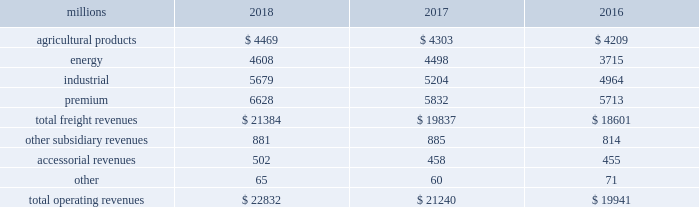Notes to the consolidated financial statements union pacific corporation and subsidiary companies for purposes of this report , unless the context otherwise requires , all references herein to the 201ccorporation 201d , 201ccompany 201d , 201cupc 201d , 201cwe 201d , 201cus 201d , and 201cour 201d mean union pacific corporation and its subsidiaries , including union pacific railroad company , which will be separately referred to herein as 201cuprr 201d or the 201crailroad 201d .
Nature of operations operations and segmentation 2013 we are a class i railroad operating in the u.s .
Our network includes 32236 route miles , linking pacific coast and gulf coast ports with the midwest and eastern u.s .
Gateways and providing several corridors to key mexican gateways .
We own 26039 miles and operate on the remainder pursuant to trackage rights or leases .
We serve the western two-thirds of the country and maintain coordinated schedules with other rail carriers for the handling of freight to and from the atlantic coast , the pacific coast , the southeast , the southwest , canada , and mexico .
Export and import traffic is moved through gulf coast and pacific coast ports and across the mexican and canadian borders .
The railroad , along with its subsidiaries and rail affiliates , is our one reportable operating segment .
Although we provide and analyze revenue by commodity group , we treat the financial results of the railroad as one segment due to the integrated nature of our rail network .
Our operating revenues are primarily derived from contracts with customers for the transportation of freight from origin to destination .
Effective january 1 , 2018 , the company reclassified its six commodity groups into four : agricultural products , energy , industrial , and premium .
The table represents a disaggregation of our freight and other revenues: .
Although our revenues are principally derived from customers domiciled in the u.s. , the ultimate points of origination or destination for some products we transport are outside the u.s .
Each of our commodity groups includes revenue from shipments to and from mexico .
Included in the above table are freight revenues from our mexico business which amounted to $ 2.5 billion in 2018 , $ 2.3 billion in 2017 , and $ 2.2 billion in 2016 .
Basis of presentation 2013 the consolidated financial statements are presented in accordance with accounting principles generally accepted in the u.s .
( gaap ) as codified in the financial accounting standards board ( fasb ) accounting standards codification ( asc ) .
Significant accounting policies principles of consolidation 2013 the consolidated financial statements include the accounts of union pacific corporation and all of its subsidiaries .
Investments in affiliated companies ( 20% ( 20 % ) to 50% ( 50 % ) owned ) are accounted for using the equity method of accounting .
All intercompany transactions are eliminated .
We currently have no less than majority-owned investments that require consolidation under variable interest entity requirements .
Cash , cash equivalents and restricted cash 2013 cash equivalents consist of investments with original maturities of three months or less .
Amounts included in restricted cash represent those required to be set aside by contractual agreement. .
Assuming the same rate of growth as in 2018 , what would industrial segment revenues grow to in 2019? 
Computations: ((5679 / 5204) * 5679)
Answer: 6197.35607. Notes to the consolidated financial statements union pacific corporation and subsidiary companies for purposes of this report , unless the context otherwise requires , all references herein to the 201ccorporation 201d , 201ccompany 201d , 201cupc 201d , 201cwe 201d , 201cus 201d , and 201cour 201d mean union pacific corporation and its subsidiaries , including union pacific railroad company , which will be separately referred to herein as 201cuprr 201d or the 201crailroad 201d .
Nature of operations operations and segmentation 2013 we are a class i railroad operating in the u.s .
Our network includes 32236 route miles , linking pacific coast and gulf coast ports with the midwest and eastern u.s .
Gateways and providing several corridors to key mexican gateways .
We own 26039 miles and operate on the remainder pursuant to trackage rights or leases .
We serve the western two-thirds of the country and maintain coordinated schedules with other rail carriers for the handling of freight to and from the atlantic coast , the pacific coast , the southeast , the southwest , canada , and mexico .
Export and import traffic is moved through gulf coast and pacific coast ports and across the mexican and canadian borders .
The railroad , along with its subsidiaries and rail affiliates , is our one reportable operating segment .
Although we provide and analyze revenue by commodity group , we treat the financial results of the railroad as one segment due to the integrated nature of our rail network .
Our operating revenues are primarily derived from contracts with customers for the transportation of freight from origin to destination .
Effective january 1 , 2018 , the company reclassified its six commodity groups into four : agricultural products , energy , industrial , and premium .
The table represents a disaggregation of our freight and other revenues: .
Although our revenues are principally derived from customers domiciled in the u.s. , the ultimate points of origination or destination for some products we transport are outside the u.s .
Each of our commodity groups includes revenue from shipments to and from mexico .
Included in the above table are freight revenues from our mexico business which amounted to $ 2.5 billion in 2018 , $ 2.3 billion in 2017 , and $ 2.2 billion in 2016 .
Basis of presentation 2013 the consolidated financial statements are presented in accordance with accounting principles generally accepted in the u.s .
( gaap ) as codified in the financial accounting standards board ( fasb ) accounting standards codification ( asc ) .
Significant accounting policies principles of consolidation 2013 the consolidated financial statements include the accounts of union pacific corporation and all of its subsidiaries .
Investments in affiliated companies ( 20% ( 20 % ) to 50% ( 50 % ) owned ) are accounted for using the equity method of accounting .
All intercompany transactions are eliminated .
We currently have no less than majority-owned investments that require consolidation under variable interest entity requirements .
Cash , cash equivalents and restricted cash 2013 cash equivalents consist of investments with original maturities of three months or less .
Amounts included in restricted cash represent those required to be set aside by contractual agreement. .
What percent of total operating revenues in 2017 were industrial? 
Computations: (5204 / 21240)
Answer: 0.24501. 